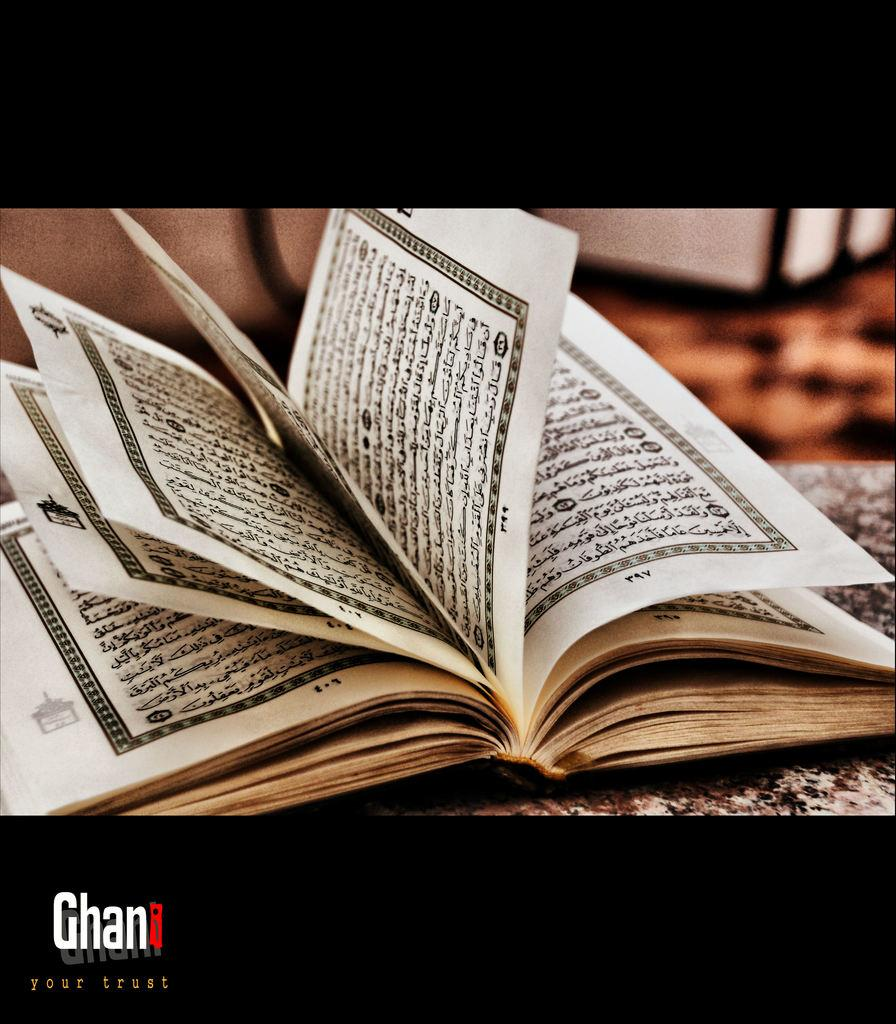<image>
Present a compact description of the photo's key features. a book with ellegible writing on the pages of it, and a logo that says Ghan on the bottom left corner 